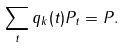<formula> <loc_0><loc_0><loc_500><loc_500>\sum _ { t } q _ { k } ( t ) P _ { t } = P .</formula> 